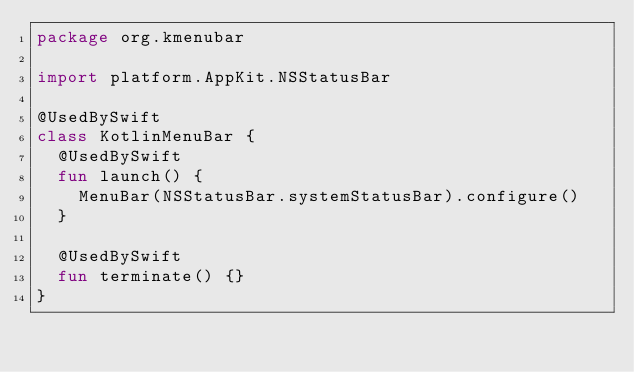<code> <loc_0><loc_0><loc_500><loc_500><_Kotlin_>package org.kmenubar

import platform.AppKit.NSStatusBar

@UsedBySwift
class KotlinMenuBar {
  @UsedBySwift
  fun launch() {
    MenuBar(NSStatusBar.systemStatusBar).configure()
  }

  @UsedBySwift
  fun terminate() {}
}
</code> 